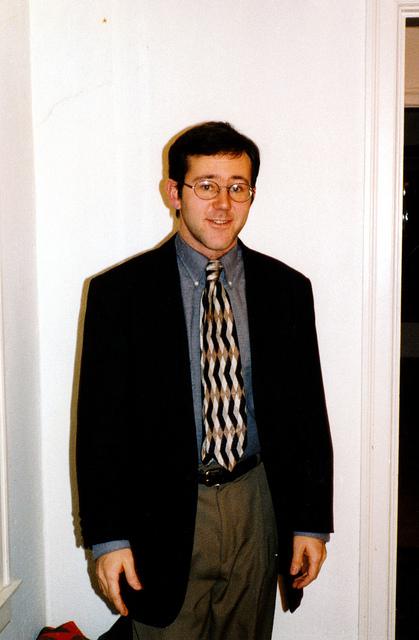Is the man dressed business casual?
Give a very brief answer. Yes. Is the man happy?
Answer briefly. Yes. Is the tie formal?
Keep it brief. No. Is the man wearing spectacles?
Be succinct. Yes. 